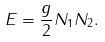Convert formula to latex. <formula><loc_0><loc_0><loc_500><loc_500>E = \frac { g } { 2 } N _ { 1 } N _ { 2 } .</formula> 